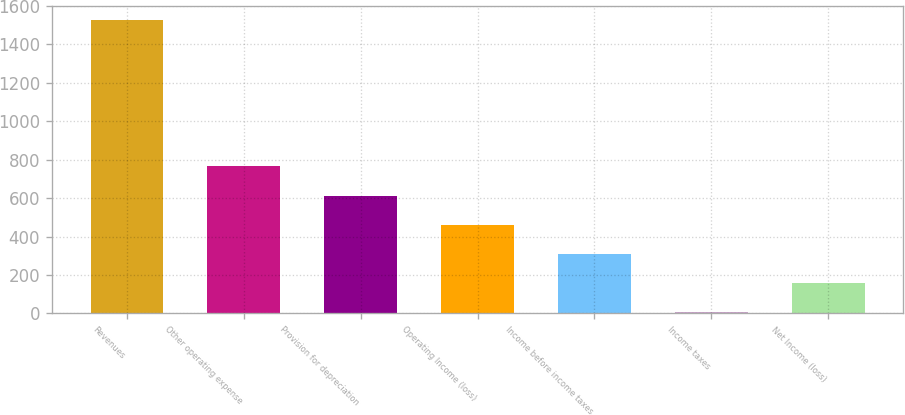Convert chart. <chart><loc_0><loc_0><loc_500><loc_500><bar_chart><fcel>Revenues<fcel>Other operating expense<fcel>Provision for depreciation<fcel>Operating Income (loss)<fcel>Income before income taxes<fcel>Income taxes<fcel>Net Income (loss)<nl><fcel>1525<fcel>765<fcel>613<fcel>461<fcel>309<fcel>5<fcel>157<nl></chart> 